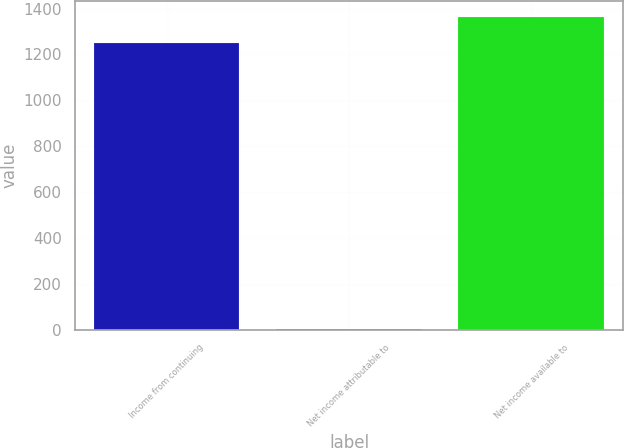Convert chart to OTSL. <chart><loc_0><loc_0><loc_500><loc_500><bar_chart><fcel>Income from continuing<fcel>Net income attributable to<fcel>Net income available to<nl><fcel>1250.6<fcel>2<fcel>1364.2<nl></chart> 